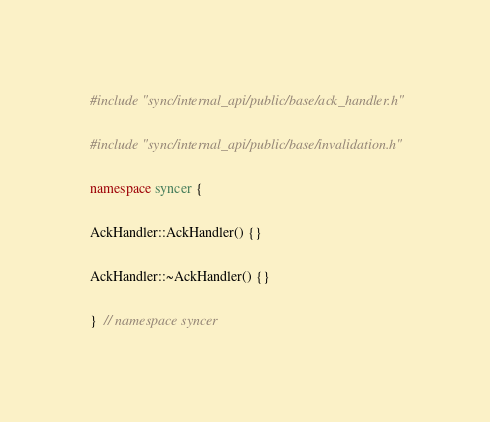<code> <loc_0><loc_0><loc_500><loc_500><_C++_>#include "sync/internal_api/public/base/ack_handler.h"

#include "sync/internal_api/public/base/invalidation.h"

namespace syncer {

AckHandler::AckHandler() {}

AckHandler::~AckHandler() {}

}  // namespace syncer
</code> 